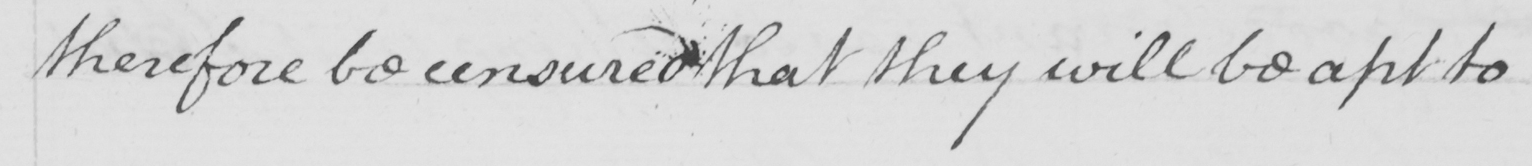What does this handwritten line say? therefore be censured that they will be apt to 